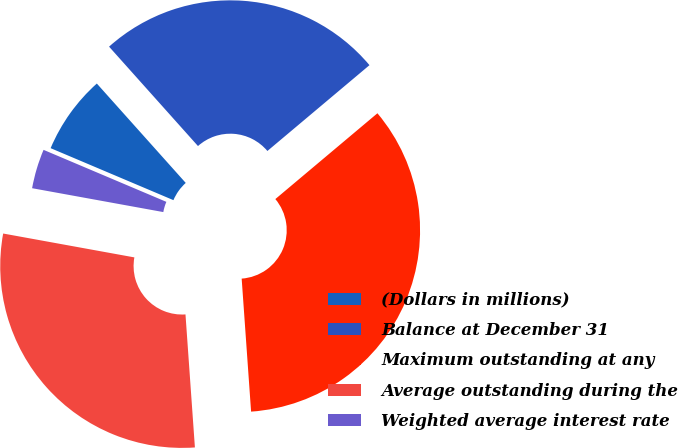<chart> <loc_0><loc_0><loc_500><loc_500><pie_chart><fcel>(Dollars in millions)<fcel>Balance at December 31<fcel>Maximum outstanding at any<fcel>Average outstanding during the<fcel>Weighted average interest rate<nl><fcel>7.01%<fcel>25.49%<fcel>35.0%<fcel>28.99%<fcel>3.51%<nl></chart> 